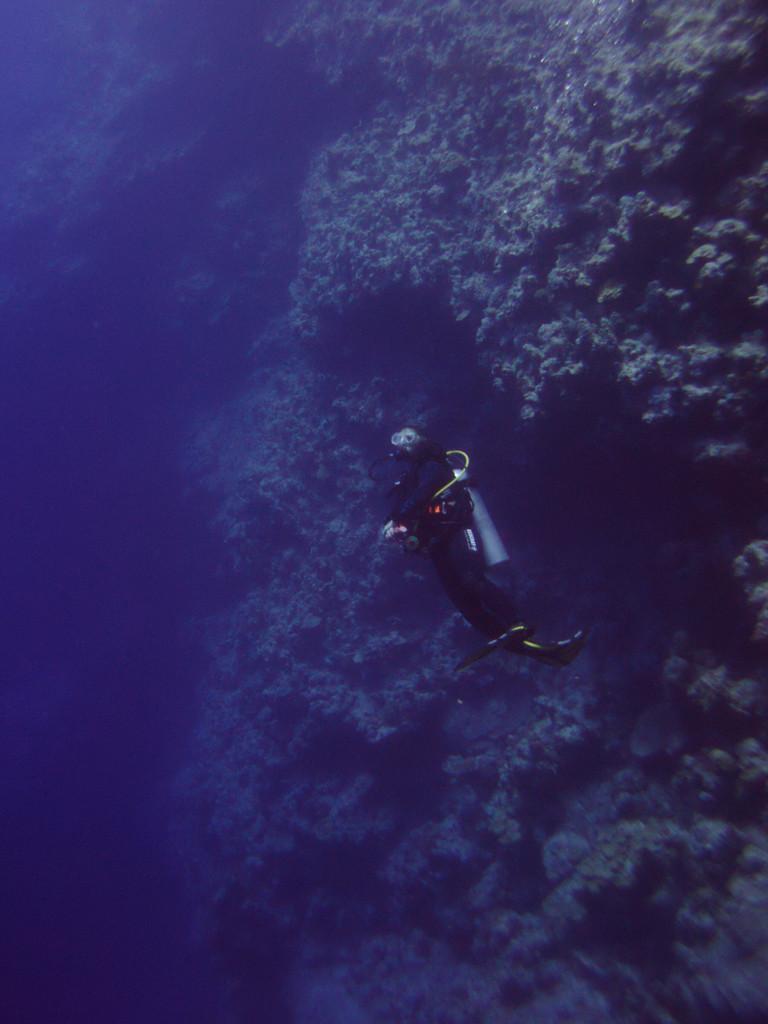In one or two sentences, can you explain what this image depicts? This image is clicked inside the water. In the center there is a person performing scuba diving. Behind him there are marine plants in the water. 